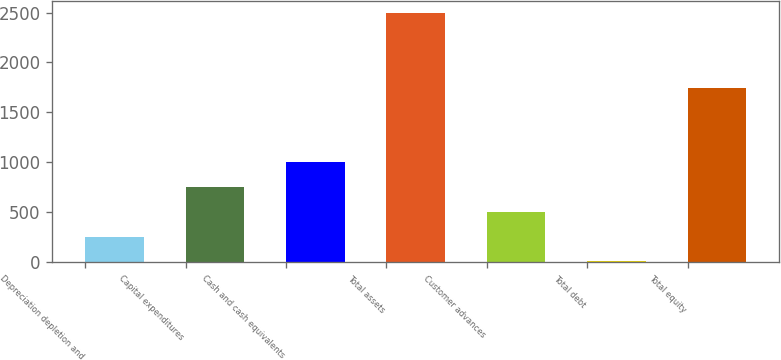Convert chart. <chart><loc_0><loc_0><loc_500><loc_500><bar_chart><fcel>Depreciation depletion and<fcel>Capital expenditures<fcel>Cash and cash equivalents<fcel>Total assets<fcel>Customer advances<fcel>Total debt<fcel>Total equity<nl><fcel>253.72<fcel>751.76<fcel>1000.78<fcel>2494.9<fcel>502.74<fcel>4.7<fcel>1744.9<nl></chart> 